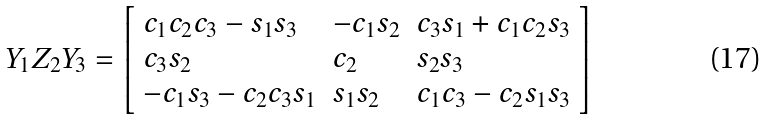Convert formula to latex. <formula><loc_0><loc_0><loc_500><loc_500>Y _ { 1 } Z _ { 2 } Y _ { 3 } = { \left [ \begin{array} { l l l } { c _ { 1 } c _ { 2 } c _ { 3 } - s _ { 1 } s _ { 3 } } & { - c _ { 1 } s _ { 2 } } & { c _ { 3 } s _ { 1 } + c _ { 1 } c _ { 2 } s _ { 3 } } \\ { c _ { 3 } s _ { 2 } } & { c _ { 2 } } & { s _ { 2 } s _ { 3 } } \\ { - c _ { 1 } s _ { 3 } - c _ { 2 } c _ { 3 } s _ { 1 } } & { s _ { 1 } s _ { 2 } } & { c _ { 1 } c _ { 3 } - c _ { 2 } s _ { 1 } s _ { 3 } } \end{array} \right ] }</formula> 